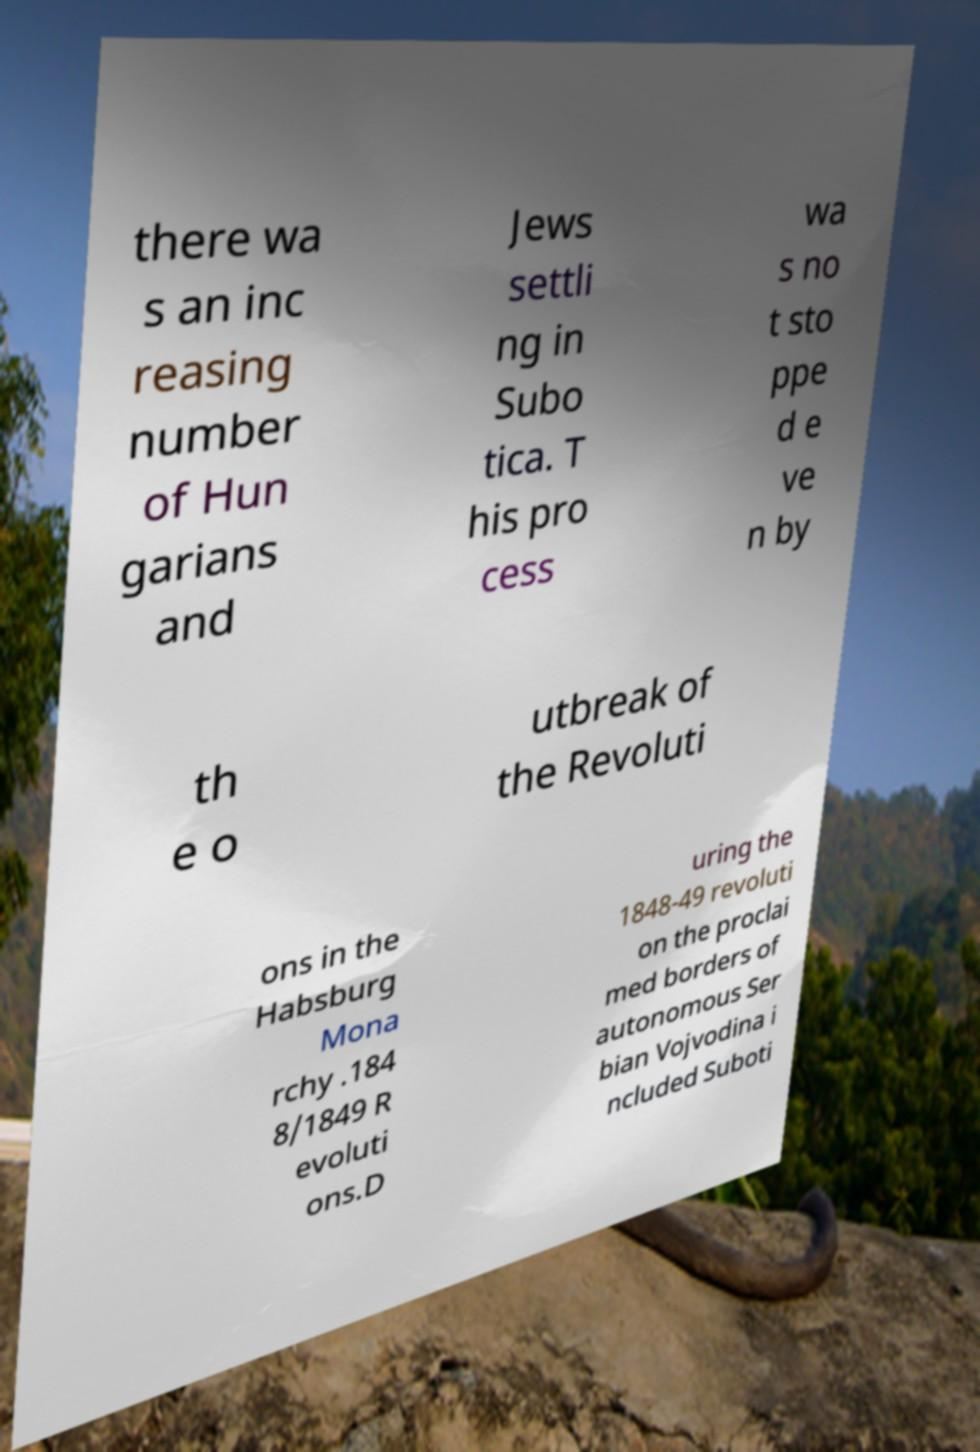Please read and relay the text visible in this image. What does it say? there wa s an inc reasing number of Hun garians and Jews settli ng in Subo tica. T his pro cess wa s no t sto ppe d e ve n by th e o utbreak of the Revoluti ons in the Habsburg Mona rchy .184 8/1849 R evoluti ons.D uring the 1848-49 revoluti on the proclai med borders of autonomous Ser bian Vojvodina i ncluded Suboti 